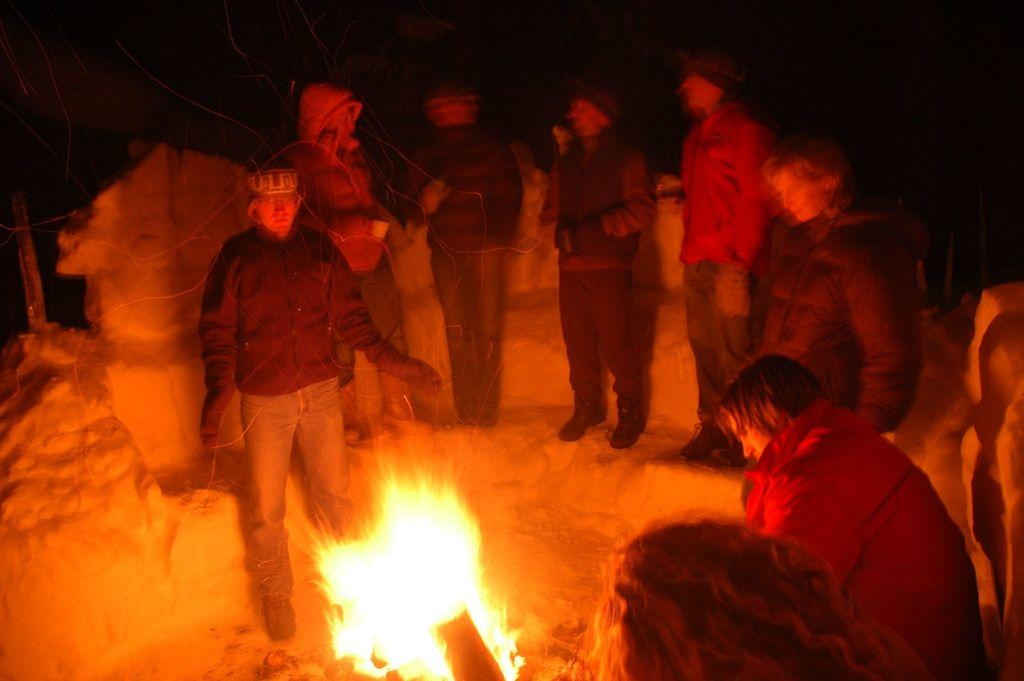What is happening in the image? There are people standing in the image. What can be seen at the bottom of the image? There is fire at the bottom of the image. What is the color of the background in the image? The background of the image is dark. How many cattle are grazing in the image? There are no cattle present in the image. What type of riddle can be solved by looking at the image? There is no riddle associated with the image, as it simply depicts people standing near fire with a dark background. 